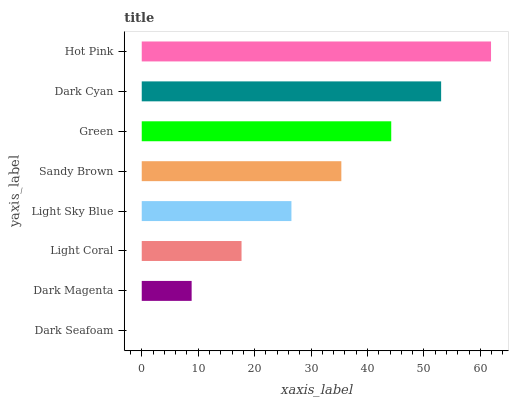Is Dark Seafoam the minimum?
Answer yes or no. Yes. Is Hot Pink the maximum?
Answer yes or no. Yes. Is Dark Magenta the minimum?
Answer yes or no. No. Is Dark Magenta the maximum?
Answer yes or no. No. Is Dark Magenta greater than Dark Seafoam?
Answer yes or no. Yes. Is Dark Seafoam less than Dark Magenta?
Answer yes or no. Yes. Is Dark Seafoam greater than Dark Magenta?
Answer yes or no. No. Is Dark Magenta less than Dark Seafoam?
Answer yes or no. No. Is Sandy Brown the high median?
Answer yes or no. Yes. Is Light Sky Blue the low median?
Answer yes or no. Yes. Is Light Coral the high median?
Answer yes or no. No. Is Dark Magenta the low median?
Answer yes or no. No. 